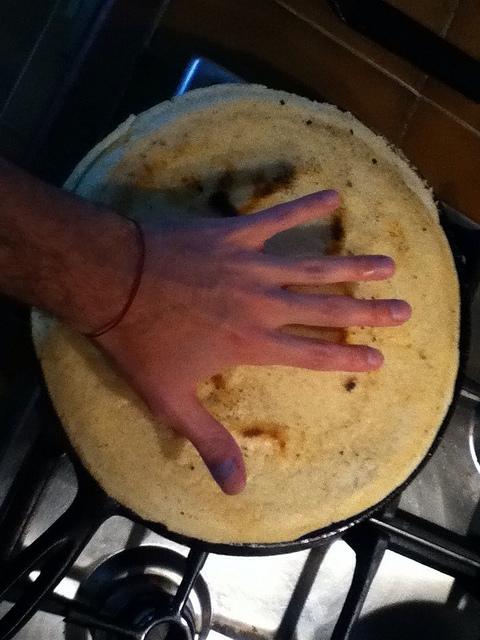What is the hand on?
Give a very brief answer. Pancake. Does this person have a rubber band around their wrist?
Answer briefly. Yes. Is the stove on or off?
Concise answer only. Off. 